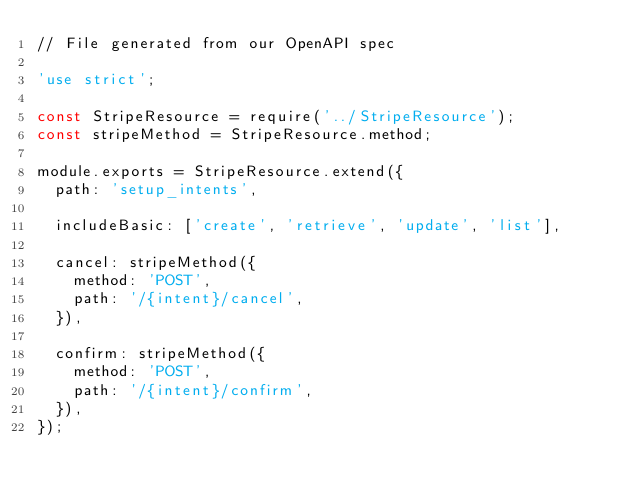Convert code to text. <code><loc_0><loc_0><loc_500><loc_500><_JavaScript_>// File generated from our OpenAPI spec

'use strict';

const StripeResource = require('../StripeResource');
const stripeMethod = StripeResource.method;

module.exports = StripeResource.extend({
  path: 'setup_intents',

  includeBasic: ['create', 'retrieve', 'update', 'list'],

  cancel: stripeMethod({
    method: 'POST',
    path: '/{intent}/cancel',
  }),

  confirm: stripeMethod({
    method: 'POST',
    path: '/{intent}/confirm',
  }),
});
</code> 